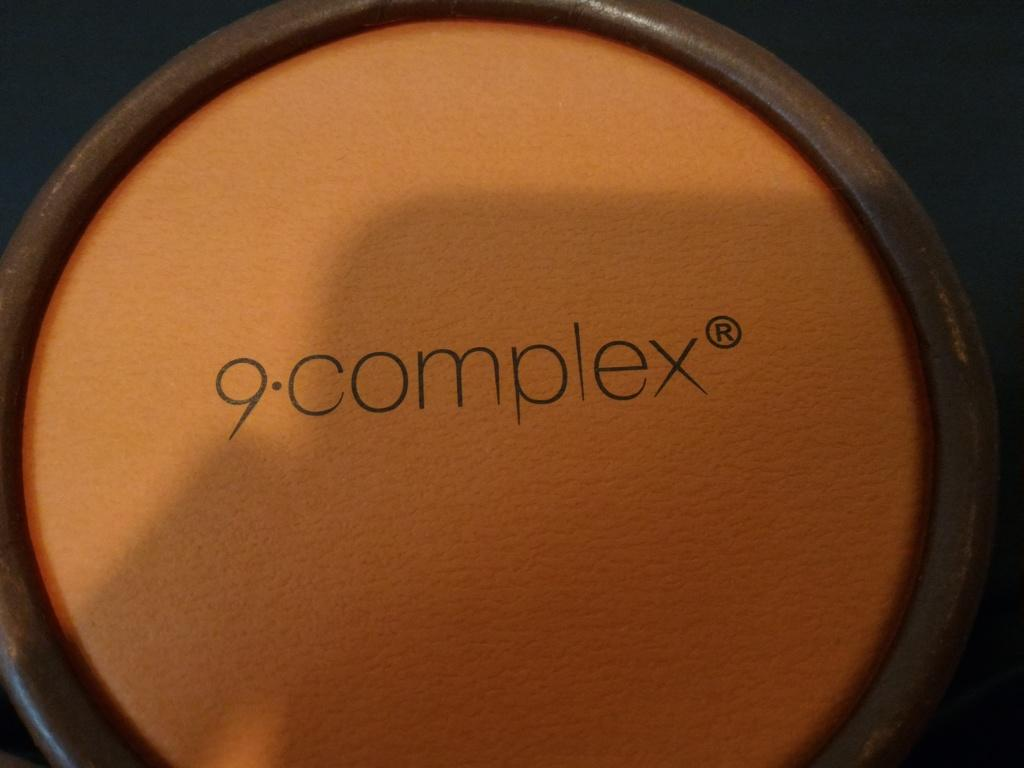<image>
Relay a brief, clear account of the picture shown. A makeup compact says 9 complex on it. 